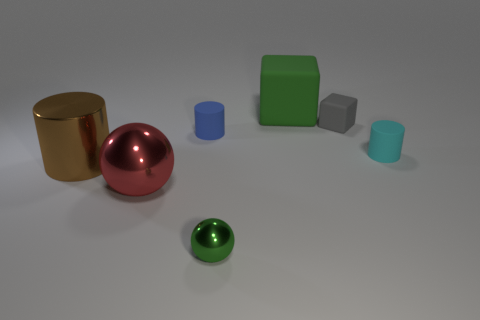Subtract all cyan cylinders. How many cylinders are left? 2 Add 3 big cyan matte spheres. How many objects exist? 10 Subtract all red balls. How many balls are left? 1 Subtract all cubes. How many objects are left? 5 Add 6 small cyan cylinders. How many small cyan cylinders exist? 7 Subtract 0 yellow blocks. How many objects are left? 7 Subtract 1 spheres. How many spheres are left? 1 Subtract all red cylinders. Subtract all purple blocks. How many cylinders are left? 3 Subtract all purple cylinders. How many purple cubes are left? 0 Subtract all red rubber things. Subtract all red things. How many objects are left? 6 